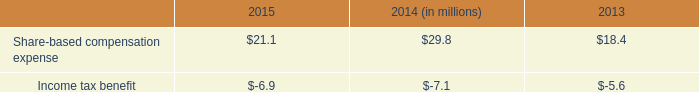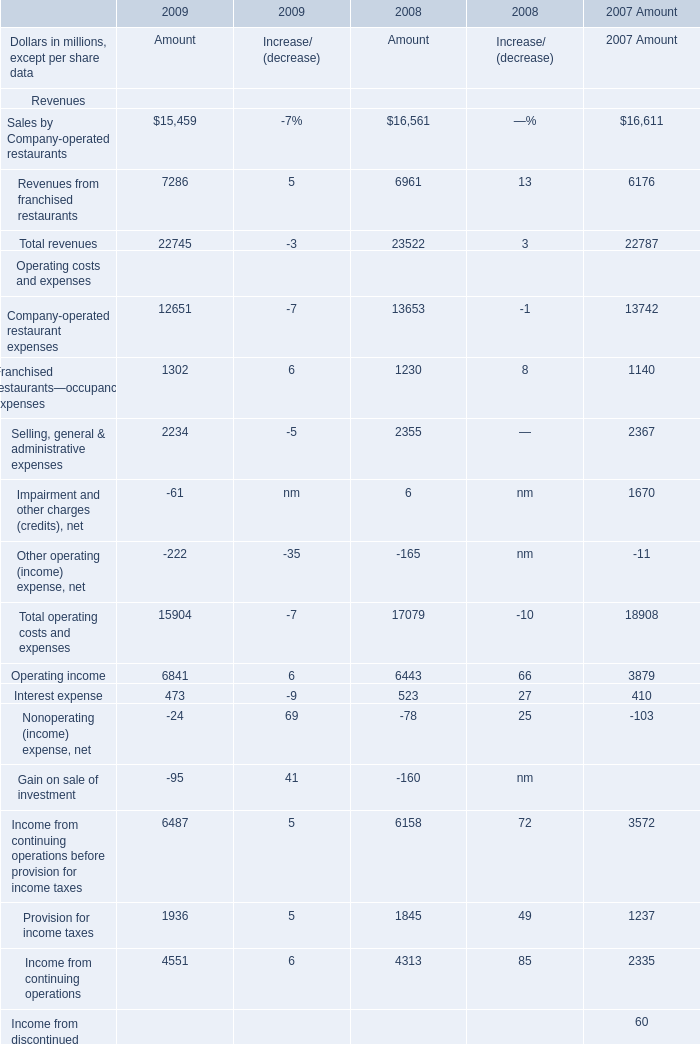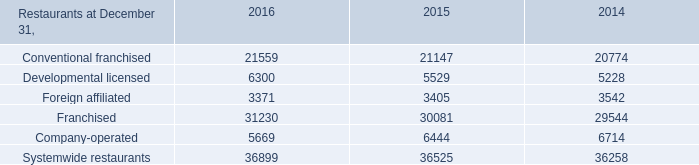What is the sum of Net income Operating costs and expenses of 2007 Amount, Developmental licensed of 2016, and Income from continuing operations before provision for income taxes Operating costs and expenses of 2009 Amount ? 
Computations: ((2395.0 + 6300.0) + 6487.0)
Answer: 15182.0. 